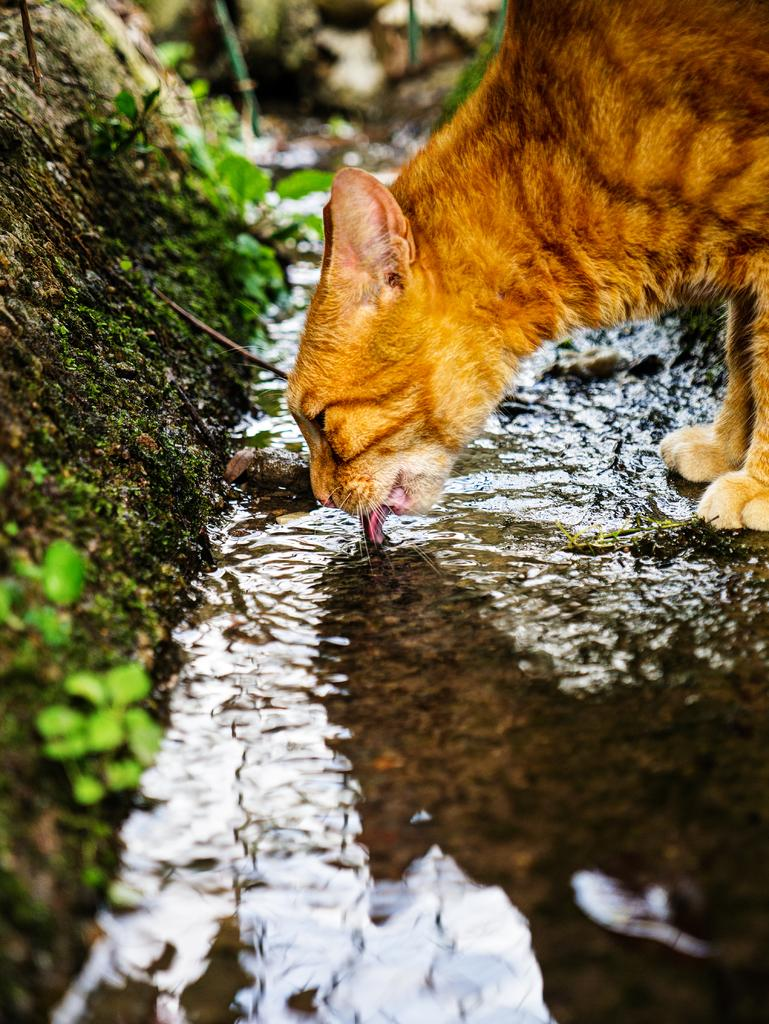What is in the foreground of the image? There is a cat in the foreground of the image. What is the cat doing in the image? The cat is drinking water. What can be seen on the left side of the image? There are plants on the left side of the image. How would you describe the background of the image? The background of the image is blurred. What type of cake is being served on the roof in the image? There is no cake or roof present in the image; it features a cat drinking water and plants on the left side. 